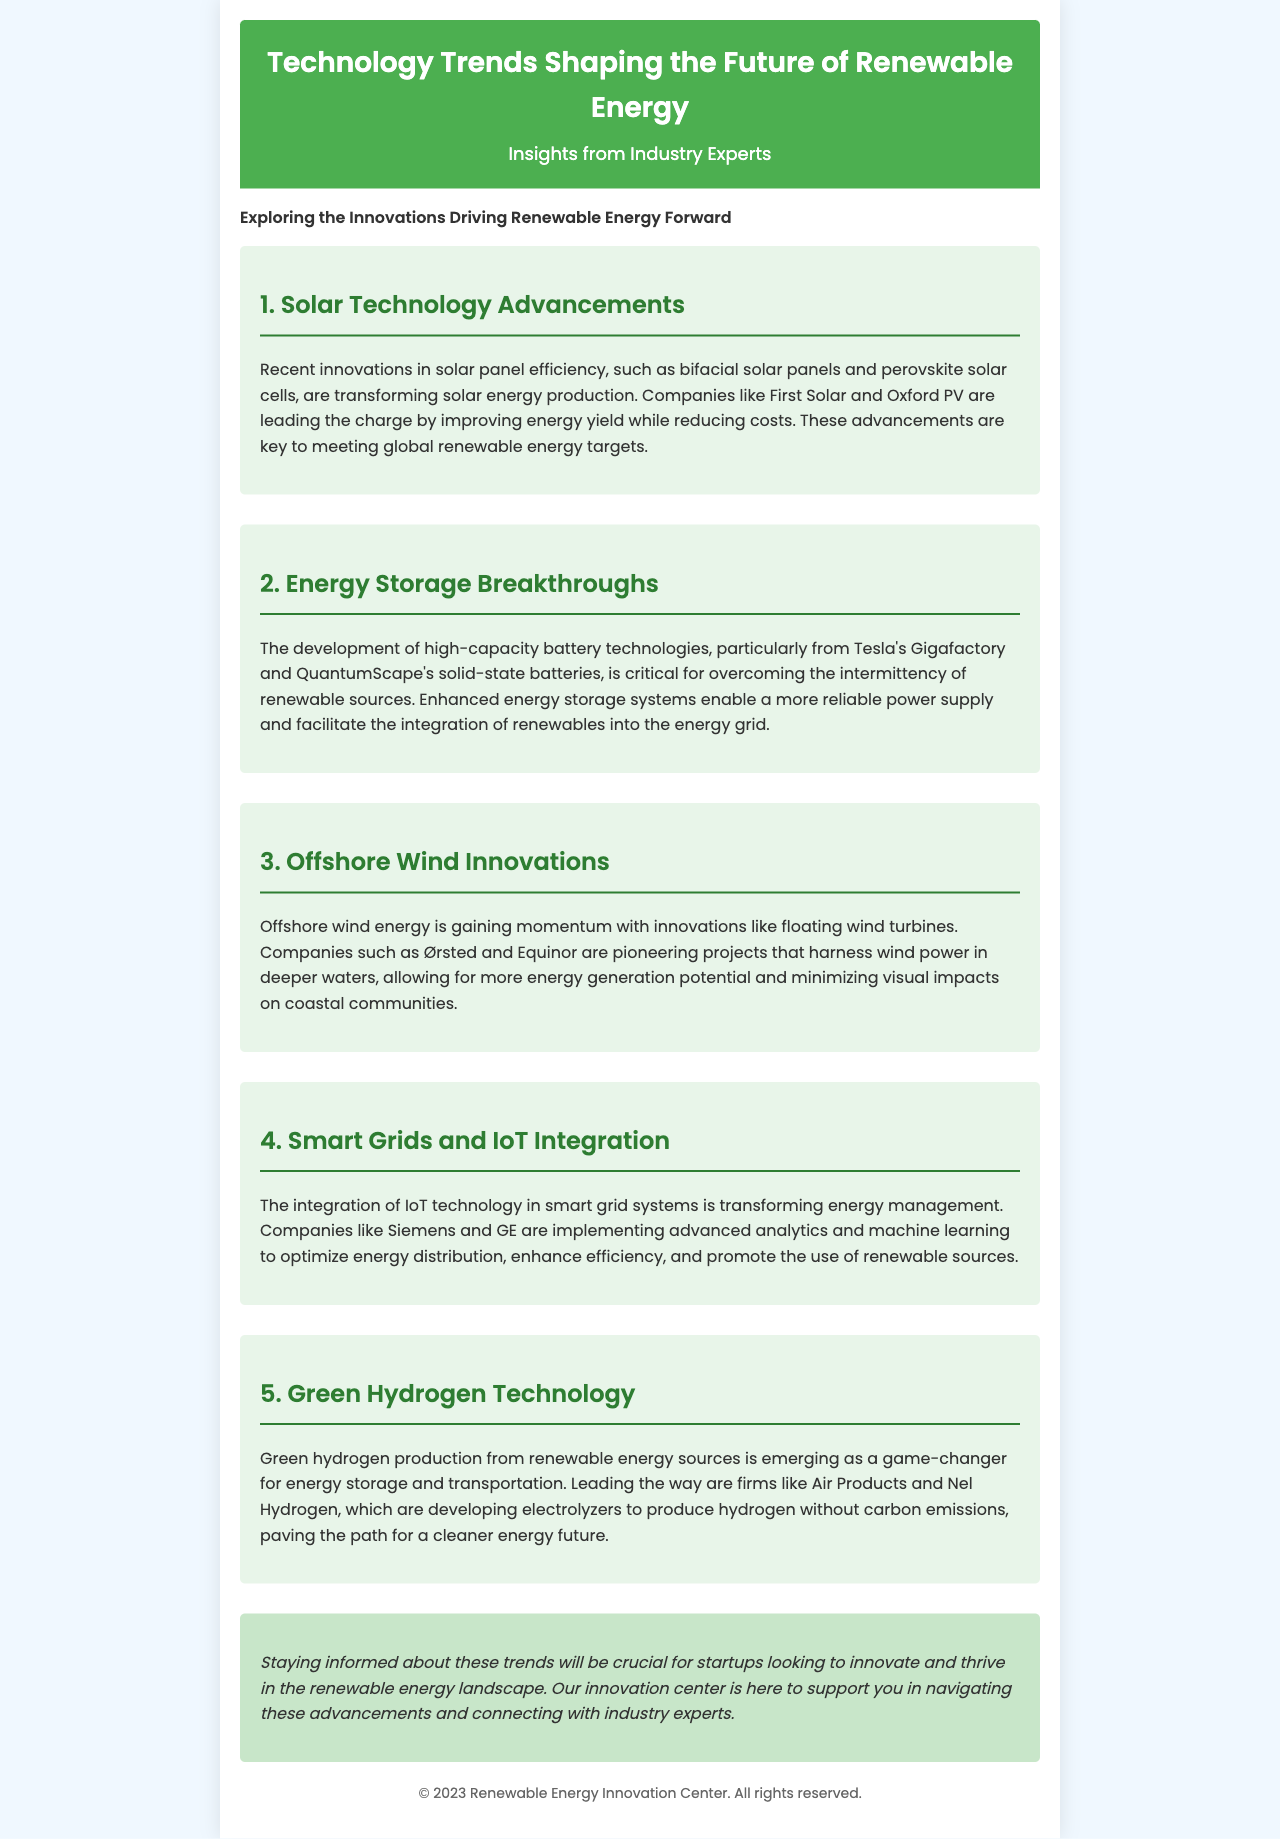What are bifacial solar panels? Bifacial solar panels are a type of solar panel that captures sunlight from both sides, enhancing energy efficiency.
Answer: Bifacial solar panels Which company is developing solid-state batteries? QuantumScape is a company leading in the development of solid-state battery technologies.
Answer: QuantumScape What type of turbines are being pioneered by Ørsted? Ørsted is pioneering floating wind turbines in offshore wind energy projects.
Answer: Floating wind turbines What technology is used to optimize energy distribution? Advanced analytics and machine learning are used to optimize energy distribution in smart grids.
Answer: Advanced analytics and machine learning Who are leading producers of green hydrogen? Air Products and Nel Hydrogen are leading producers of green hydrogen technology.
Answer: Air Products and Nel Hydrogen What is the significance of energy storage systems? Enhanced energy storage systems enable a more reliable power supply and facilitate renewable energy integration.
Answer: Reliable power supply How many technology trends are discussed in the newsletter? The newsletter discusses five technology trends shaping the future of renewable energy.
Answer: Five What is the primary focus of the Renewable Energy Innovation Center? The primary focus of the center is to support startups in navigating advancements in renewable energy technology.
Answer: Support startups What is mentioned as a critical factor for renewable sources? High-capacity battery technologies are mentioned as critical for overcoming the intermittency of renewable sources.
Answer: High-capacity battery technologies 